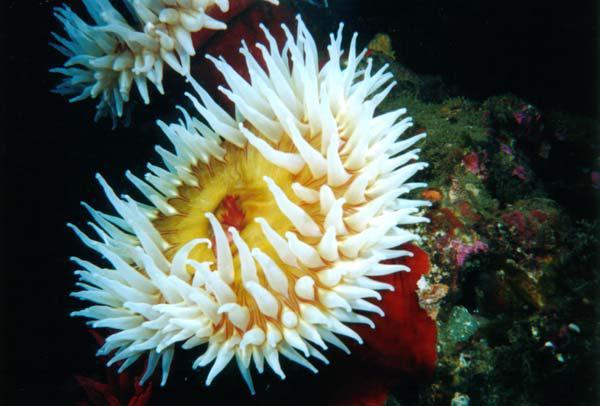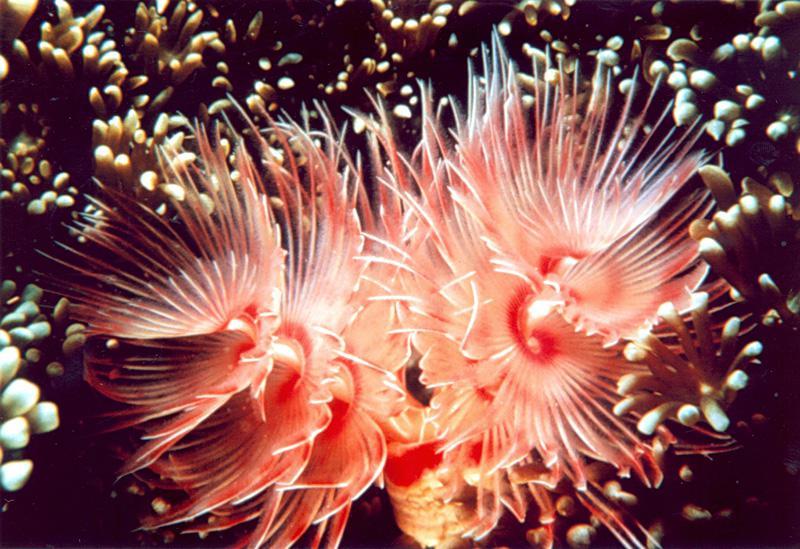The first image is the image on the left, the second image is the image on the right. Given the left and right images, does the statement "An image shows an anemone with lavender tendrils that taper distinctly." hold true? Answer yes or no. No. The first image is the image on the left, the second image is the image on the right. Assess this claim about the two images: "One of the sea creatures is yellowish in color and the other is pink.". Correct or not? Answer yes or no. Yes. 